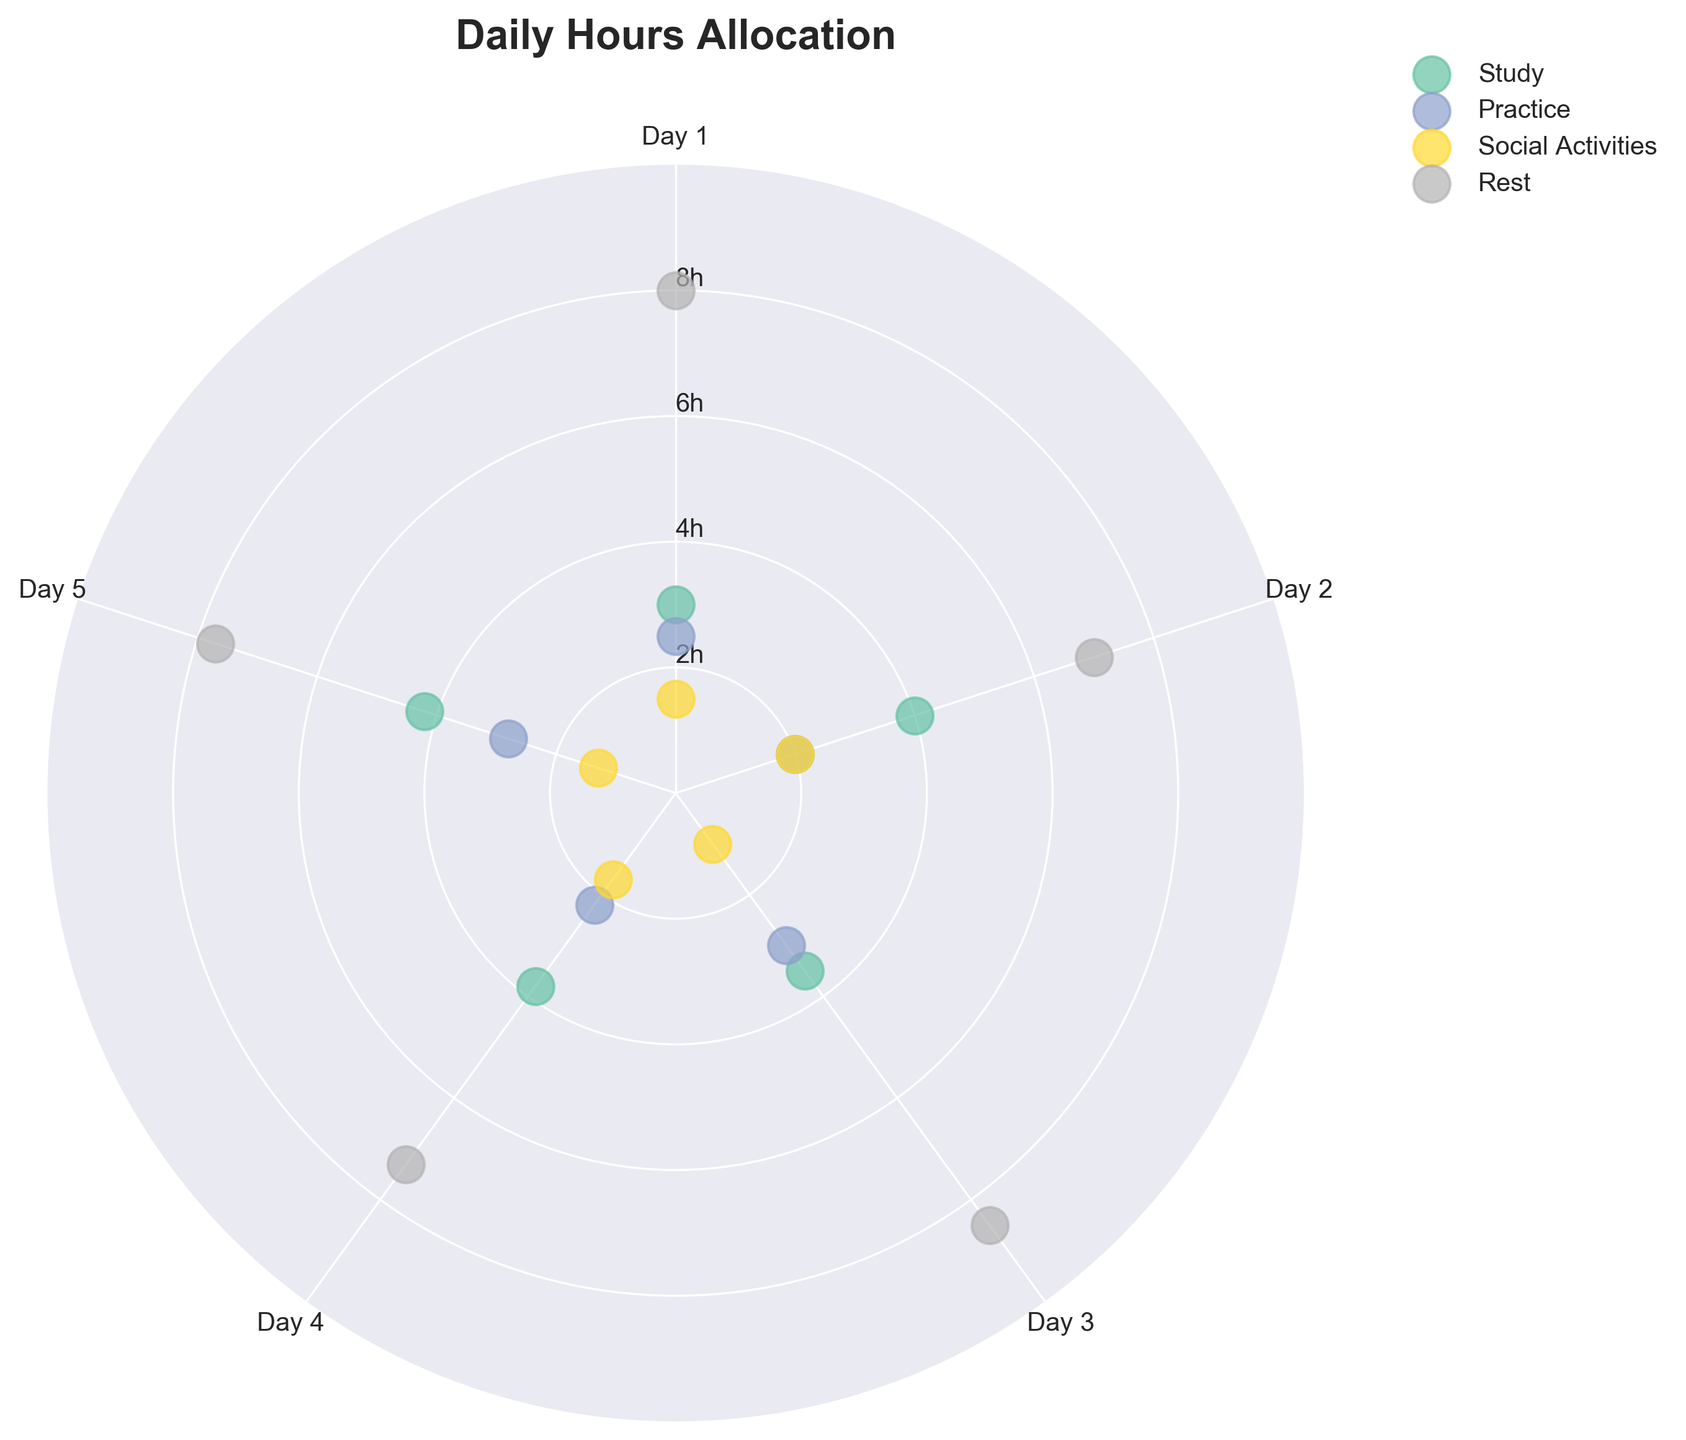What is the title of the chart? The title is usually displayed at the top of the chart. From the description, the title is given as "Daily Hours Allocation."
Answer: Daily Hours Allocation Which activity has the highest number of hours on Day 1? To answer this, look at the first set of data points (around 0 radians) and identify which activity has the largest radial distance. In this case, Rest has the highest value at 8 hours.
Answer: Rest What are the minimum and maximum hours spent on Social Activities? Review the radial distances for Social Activities across all data points. The minimum is 1 hour, and the maximum is 2 hours.
Answer: 1 and 2 hours Calculate the average daily hours for Practice over the five days. Sum up all hours for Practice (2.5 + 2 + 3 + 2.2 + 2.8) = 12.5 hours, then divide by 5 (number of days). The average is 12.5 / 5 = 2.5 hours.
Answer: 2.5 hours Which day shows the highest total allocation of hours? Calculate the total hours for each day by summing the values for Study, Practice, Social Activities, and Rest for days across each theta value. Day 3 (3.5 + 3 + 1 + 8.5) = 16 hours is the highest.
Answer: Day 3 Compare the Study hours on Day 2 and Day 5. Which day has more Study hours? Find the Study hours for Day 2 (4 hours) and for Day 5 (4.2 hours) and compare them.
Answer: Day 5 How do the Rest hours vary across the days? Look at the Rest hours data points and notice the pattern: 8, 7, 8.5, 7.3, and 7.7 hours. There is some fluctuation but generally stays between 7 and 8.5 hours.
Answer: Vary between 7 and 8.5 hours Is there any day where the Social Activities hours exceed the Practice hours? Compare the Social Activities and Practice hours for each day. None of the days have Social Activities hours exceeding Practice hours.
Answer: No What's the standard deviation of the Study hours? Calculate the standard deviation for the Study hours: mean = 3.7, individual variances (0.7^2, 0.3^2, 0.2^2, 0.1^2, 0.5^2), then sqrt(sum of variances / number of points).
Answer: ≈0.5 hours 